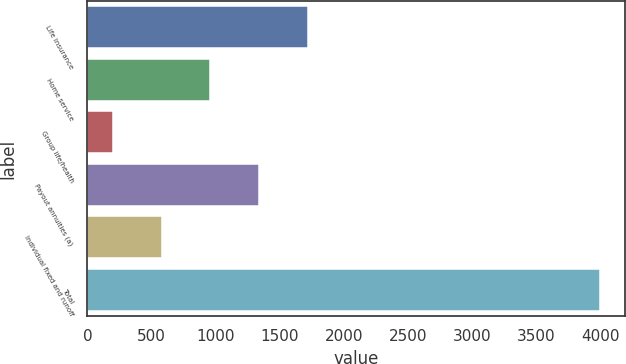<chart> <loc_0><loc_0><loc_500><loc_500><bar_chart><fcel>Life insurance<fcel>Home service<fcel>Group life/health<fcel>Payout annuities (a)<fcel>Individual fixed and runoff<fcel>Total<nl><fcel>1718<fcel>959<fcel>200<fcel>1338.5<fcel>579.5<fcel>3995<nl></chart> 